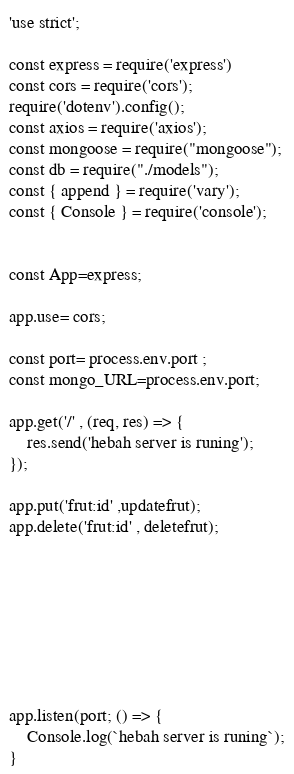<code> <loc_0><loc_0><loc_500><loc_500><_JavaScript_>'use strict';

const express = require('express')
const cors = require('cors');
require('dotenv').config();
const axios = require('axios');
const mongoose = require("mongoose");
const db = require("./models");
const { append } = require('vary');
const { Console } = require('console');


const App=express;

app.use= cors;

const port= process.env.port ;
const mongo_URL=process.env.port;

app.get('/' , (req, res) => {
    res.send('hebah server is runing');
});

app.put('frut:id' ,updatefrut);
app.delete('frut:id' , deletefrut);








app.listen(port; () => {
    Console.log(`hebah server is runing`);
}

</code> 